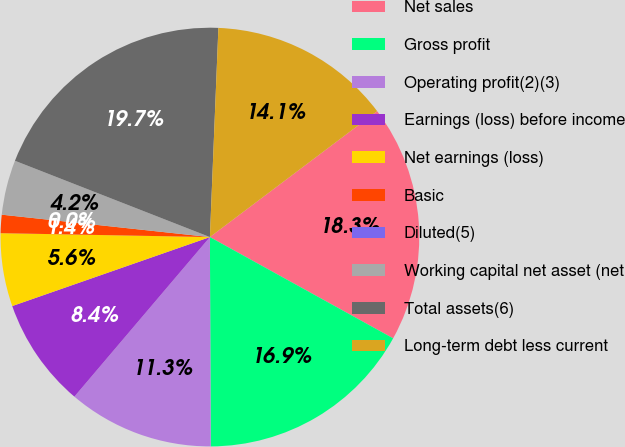Convert chart. <chart><loc_0><loc_0><loc_500><loc_500><pie_chart><fcel>Net sales<fcel>Gross profit<fcel>Operating profit(2)(3)<fcel>Earnings (loss) before income<fcel>Net earnings (loss)<fcel>Basic<fcel>Diluted(5)<fcel>Working capital net asset (net<fcel>Total assets(6)<fcel>Long-term debt less current<nl><fcel>18.31%<fcel>16.9%<fcel>11.27%<fcel>8.45%<fcel>5.64%<fcel>1.41%<fcel>0.0%<fcel>4.23%<fcel>19.71%<fcel>14.08%<nl></chart> 